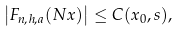Convert formula to latex. <formula><loc_0><loc_0><loc_500><loc_500>\left | F _ { n , h , a } ( N x ) \right | \leq C ( x _ { 0 } , s ) ,</formula> 